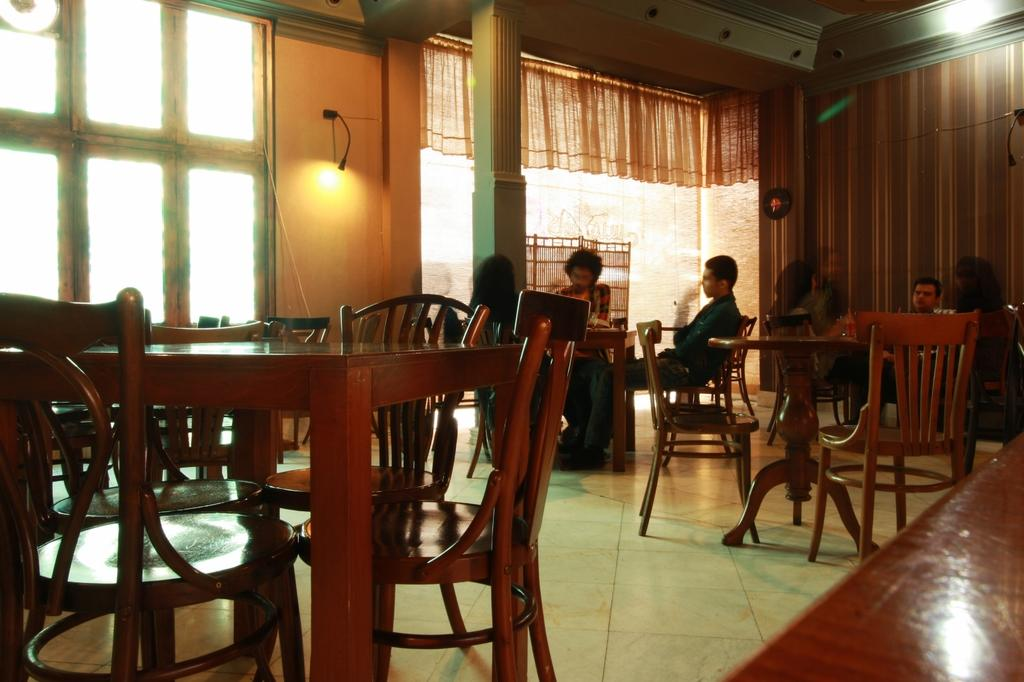What type of furniture is present in the image? There are chairs and tables in the image. What are the people in the image doing? There are people sitting on the chairs in the image. What can be seen above the tables in the image? There is a light in the image. What is visible on the wall in the image? There is a window with a curtain associated with it in the image. What type of deer can be seen providing advice to the people in the image? There is no deer present in the image, and therefore no such advice-giving can be observed. What type of fuel is being used by the people in the image? There is no mention of fuel or any related activity in the image. 